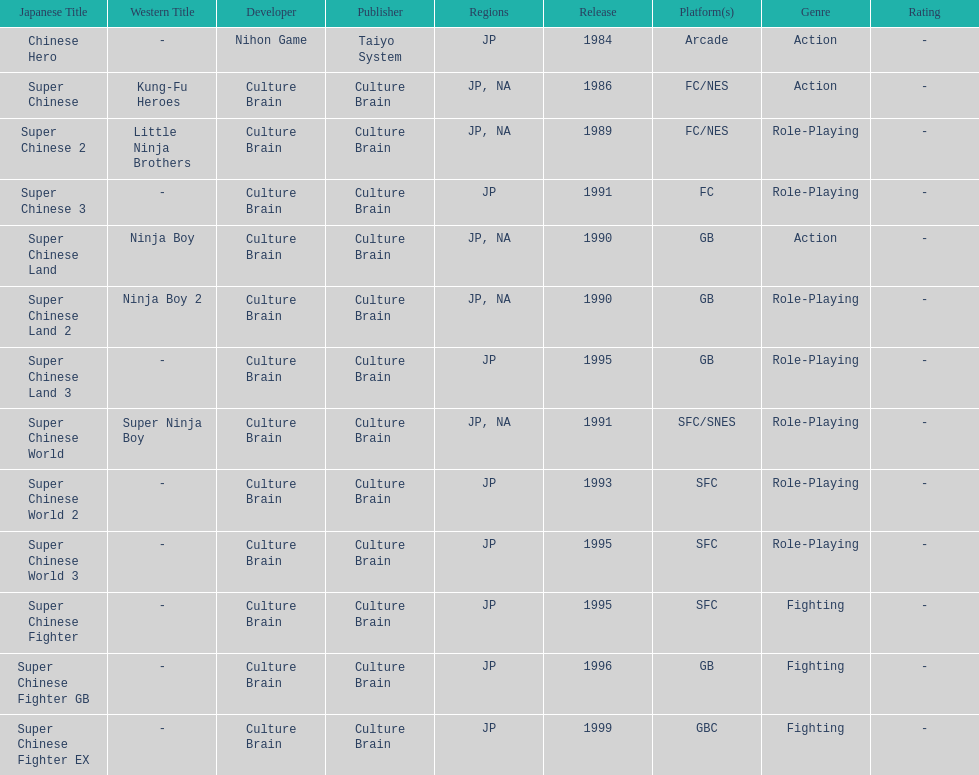Of the titles released in north america, which had the least releases? Super Chinese World. 